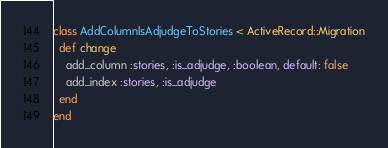<code> <loc_0><loc_0><loc_500><loc_500><_Ruby_>class AddColumnIsAdjudgeToStories < ActiveRecord::Migration
  def change
    add_column :stories, :is_adjudge, :boolean, default: false
    add_index :stories, :is_adjudge
  end
end
</code> 